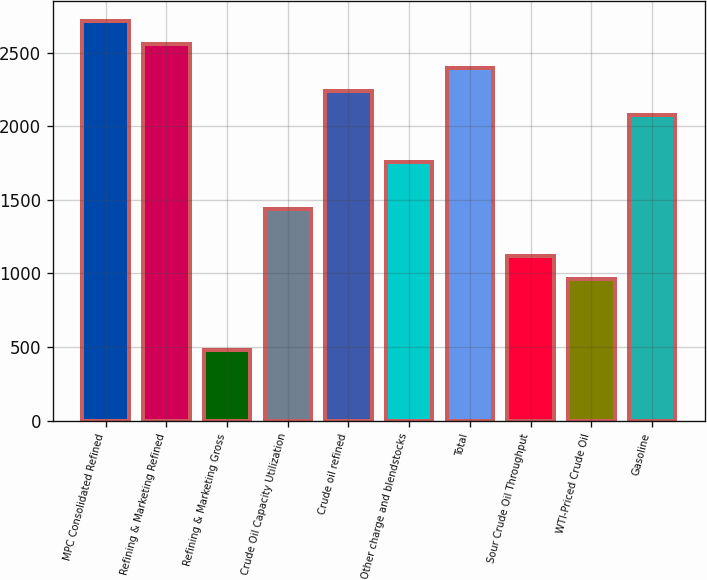Convert chart. <chart><loc_0><loc_0><loc_500><loc_500><bar_chart><fcel>MPC Consolidated Refined<fcel>Refining & Marketing Refined<fcel>Refining & Marketing Gross<fcel>Crude Oil Capacity Utilization<fcel>Crude oil refined<fcel>Other charge and blendstocks<fcel>Total<fcel>Sour Crude Oil Throughput<fcel>WTI-Priced Crude Oil<fcel>Gasoline<nl><fcel>2717.72<fcel>2557.9<fcel>480.24<fcel>1439.16<fcel>2238.26<fcel>1758.8<fcel>2398.08<fcel>1119.52<fcel>959.7<fcel>2078.44<nl></chart> 